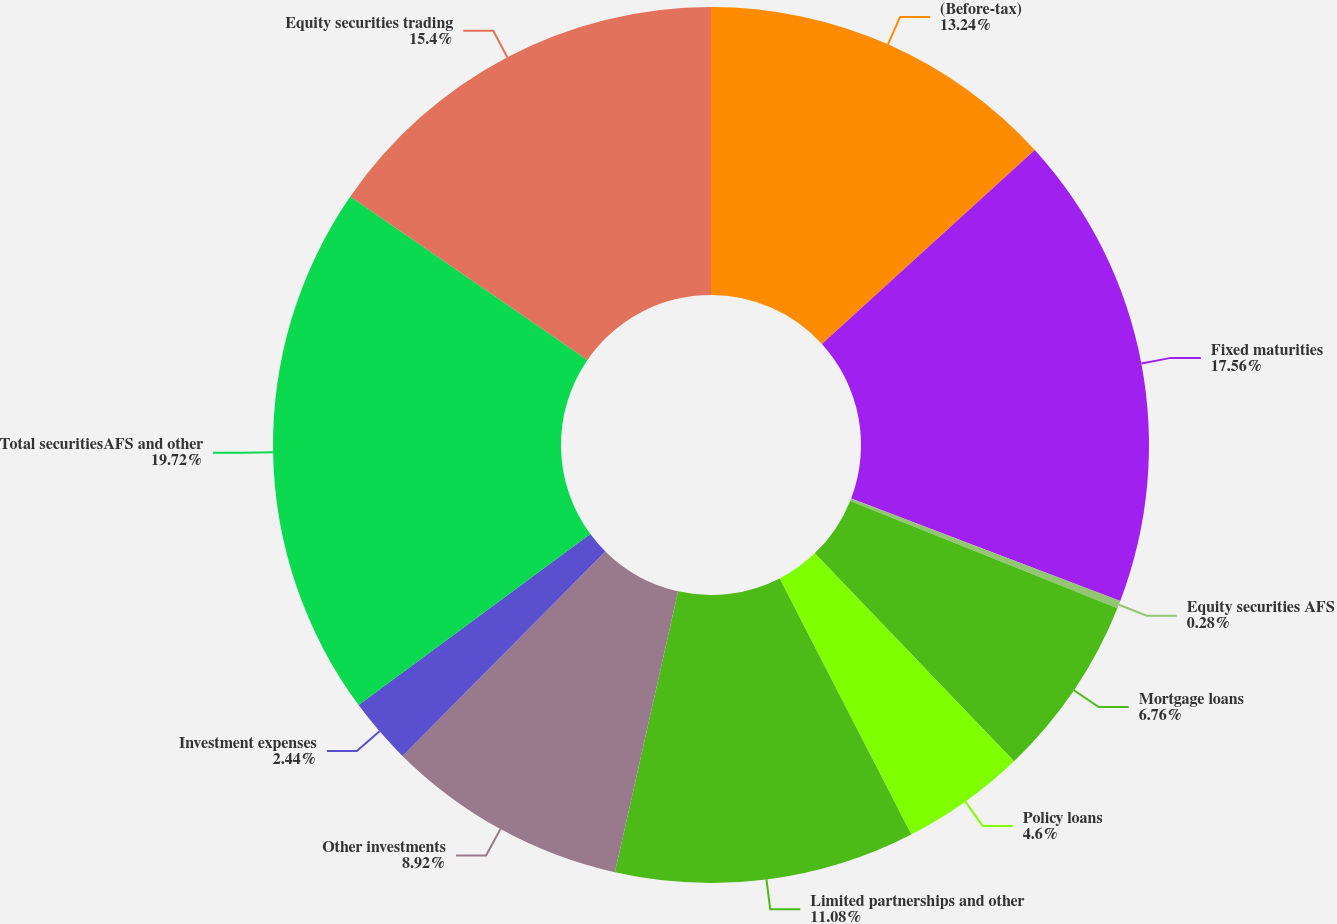<chart> <loc_0><loc_0><loc_500><loc_500><pie_chart><fcel>(Before-tax)<fcel>Fixed maturities<fcel>Equity securities AFS<fcel>Mortgage loans<fcel>Policy loans<fcel>Limited partnerships and other<fcel>Other investments<fcel>Investment expenses<fcel>Total securitiesAFS and other<fcel>Equity securities trading<nl><fcel>13.24%<fcel>17.56%<fcel>0.28%<fcel>6.76%<fcel>4.6%<fcel>11.08%<fcel>8.92%<fcel>2.44%<fcel>19.72%<fcel>15.4%<nl></chart> 